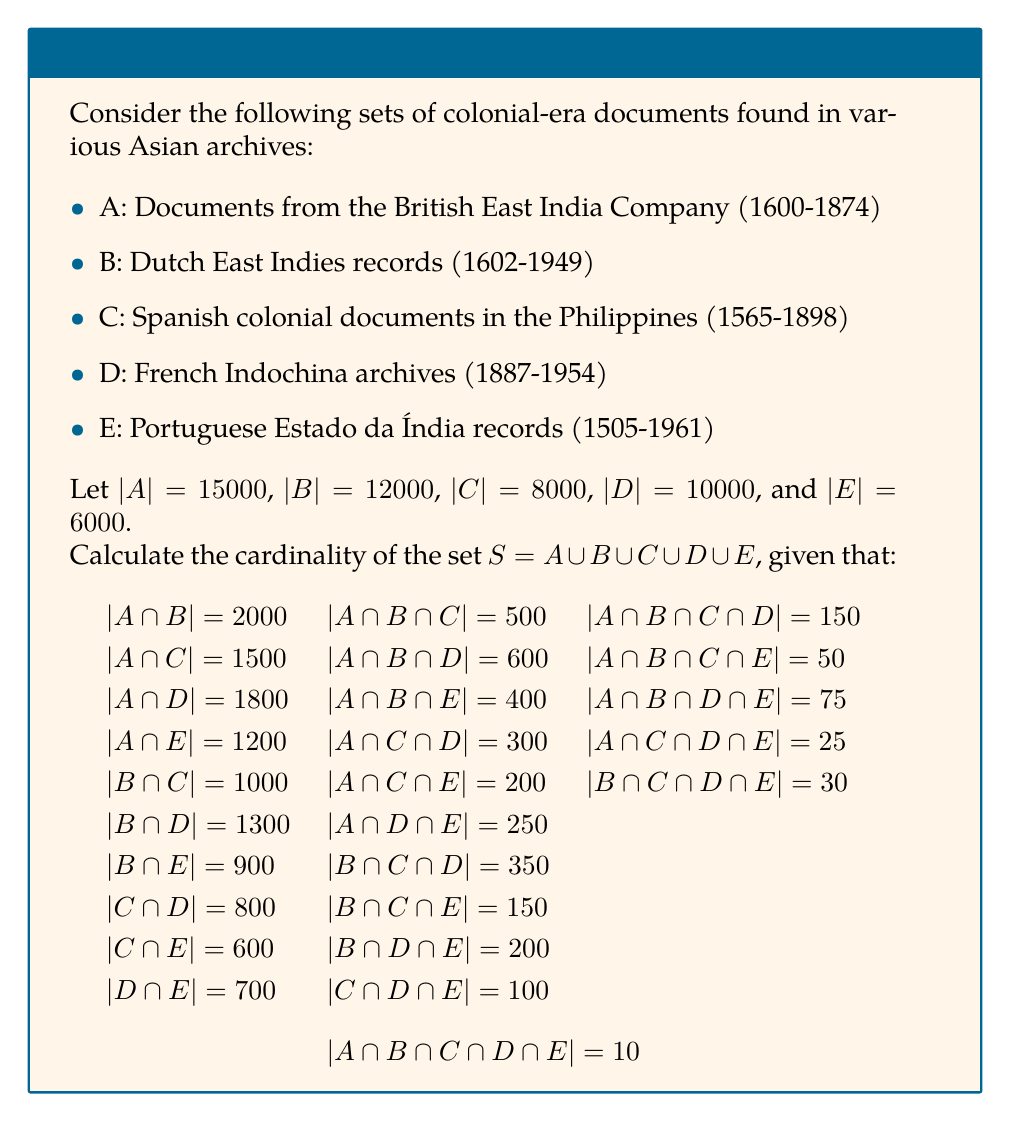Could you help me with this problem? To solve this problem, we'll use the Principle of Inclusion-Exclusion (PIE) for five sets. The formula is:

$$|S| = \sum_{i=1}^5 |A_i| - \sum_{1 \leq i < j \leq 5} |A_i \cap A_j| + \sum_{1 \leq i < j < k \leq 5} |A_i \cap A_j \cap A_k| - \sum_{1 \leq i < j < k < l \leq 5} |A_i \cap A_j \cap A_k \cap A_l| + |A_1 \cap A_2 \cap A_3 \cap A_4 \cap A_5|$$

Let's calculate each part:

1. Sum of individual set cardinalities:
   $|A| + |B| + |C| + |D| + |E| = 15000 + 12000 + 8000 + 10000 + 6000 = 51000$

2. Sum of pairwise intersections:
   $2000 + 1500 + 1800 + 1200 + 1000 + 1300 + 900 + 800 + 600 + 700 = 11800$

3. Sum of triple intersections:
   $500 + 600 + 400 + 300 + 200 + 250 + 350 + 150 + 200 + 100 = 3050$

4. Sum of quadruple intersections:
   $150 + 50 + 75 + 25 + 30 = 330$

5. Intersection of all five sets:
   $10$

Now, we can apply the PIE formula:

$|S| = 51000 - 11800 + 3050 - 330 + 10 = 41930$

Therefore, the cardinality of set $S$ is 41,930.
Answer: 41,930 